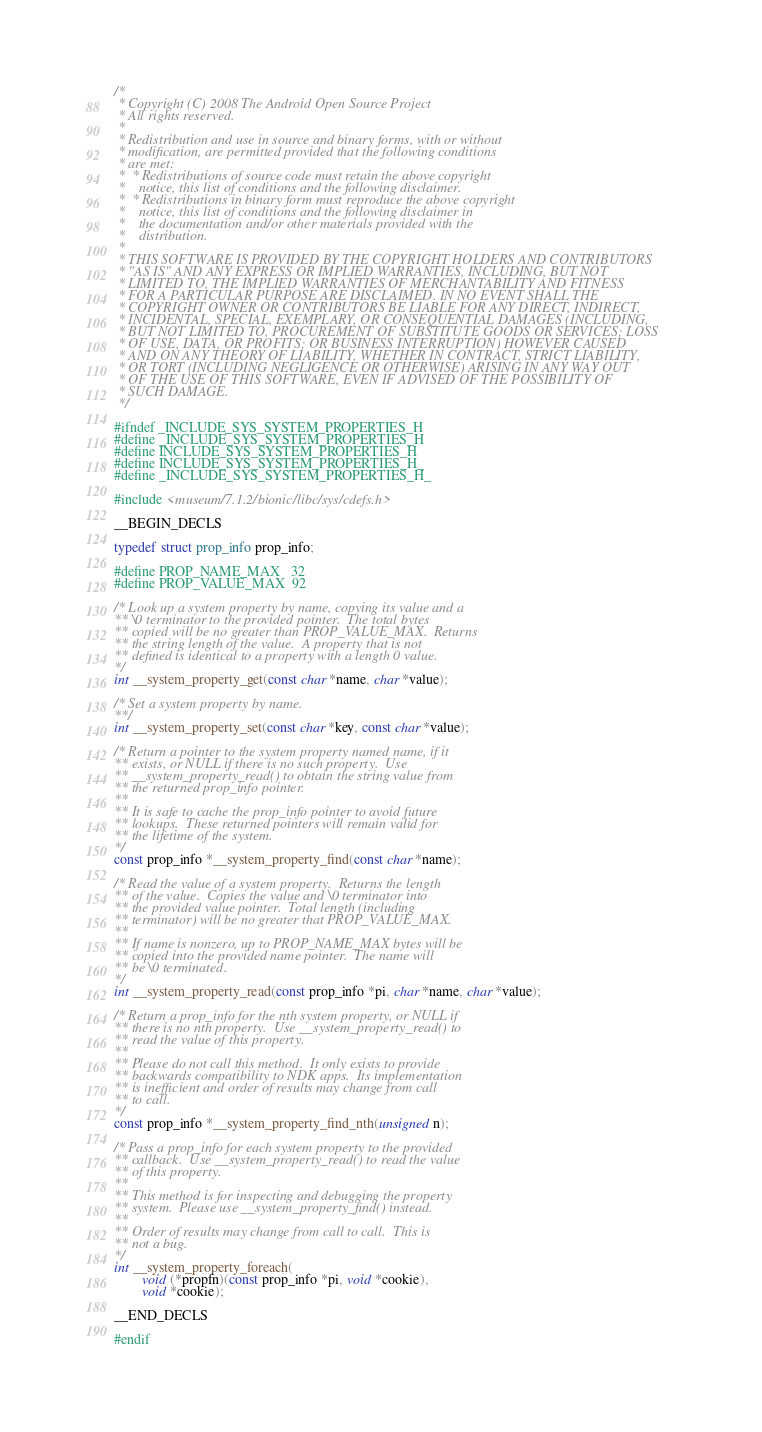Convert code to text. <code><loc_0><loc_0><loc_500><loc_500><_C_>/*
 * Copyright (C) 2008 The Android Open Source Project
 * All rights reserved.
 *
 * Redistribution and use in source and binary forms, with or without
 * modification, are permitted provided that the following conditions
 * are met:
 *  * Redistributions of source code must retain the above copyright
 *    notice, this list of conditions and the following disclaimer.
 *  * Redistributions in binary form must reproduce the above copyright
 *    notice, this list of conditions and the following disclaimer in
 *    the documentation and/or other materials provided with the
 *    distribution.
 *
 * THIS SOFTWARE IS PROVIDED BY THE COPYRIGHT HOLDERS AND CONTRIBUTORS
 * "AS IS" AND ANY EXPRESS OR IMPLIED WARRANTIES, INCLUDING, BUT NOT
 * LIMITED TO, THE IMPLIED WARRANTIES OF MERCHANTABILITY AND FITNESS
 * FOR A PARTICULAR PURPOSE ARE DISCLAIMED. IN NO EVENT SHALL THE
 * COPYRIGHT OWNER OR CONTRIBUTORS BE LIABLE FOR ANY DIRECT, INDIRECT,
 * INCIDENTAL, SPECIAL, EXEMPLARY, OR CONSEQUENTIAL DAMAGES (INCLUDING,
 * BUT NOT LIMITED TO, PROCUREMENT OF SUBSTITUTE GOODS OR SERVICES; LOSS
 * OF USE, DATA, OR PROFITS; OR BUSINESS INTERRUPTION) HOWEVER CAUSED
 * AND ON ANY THEORY OF LIABILITY, WHETHER IN CONTRACT, STRICT LIABILITY,
 * OR TORT (INCLUDING NEGLIGENCE OR OTHERWISE) ARISING IN ANY WAY OUT
 * OF THE USE OF THIS SOFTWARE, EVEN IF ADVISED OF THE POSSIBILITY OF
 * SUCH DAMAGE.
 */

#ifndef _INCLUDE_SYS_SYSTEM_PROPERTIES_H
#define _INCLUDE_SYS_SYSTEM_PROPERTIES_H
#define INCLUDE_SYS_SYSTEM_PROPERTIES_H
#define INCLUDE_SYS_SYSTEM_PROPERTIES_H_
#define _INCLUDE_SYS_SYSTEM_PROPERTIES_H_

#include <museum/7.1.2/bionic/libc/sys/cdefs.h>

__BEGIN_DECLS

typedef struct prop_info prop_info;

#define PROP_NAME_MAX   32
#define PROP_VALUE_MAX  92

/* Look up a system property by name, copying its value and a
** \0 terminator to the provided pointer.  The total bytes
** copied will be no greater than PROP_VALUE_MAX.  Returns
** the string length of the value.  A property that is not
** defined is identical to a property with a length 0 value.
*/
int __system_property_get(const char *name, char *value);

/* Set a system property by name.
**/
int __system_property_set(const char *key, const char *value);

/* Return a pointer to the system property named name, if it
** exists, or NULL if there is no such property.  Use 
** __system_property_read() to obtain the string value from
** the returned prop_info pointer.
**
** It is safe to cache the prop_info pointer to avoid future
** lookups.  These returned pointers will remain valid for
** the lifetime of the system.
*/
const prop_info *__system_property_find(const char *name);

/* Read the value of a system property.  Returns the length
** of the value.  Copies the value and \0 terminator into
** the provided value pointer.  Total length (including
** terminator) will be no greater that PROP_VALUE_MAX.
**
** If name is nonzero, up to PROP_NAME_MAX bytes will be
** copied into the provided name pointer.  The name will
** be \0 terminated.
*/
int __system_property_read(const prop_info *pi, char *name, char *value);

/* Return a prop_info for the nth system property, or NULL if 
** there is no nth property.  Use __system_property_read() to
** read the value of this property.
**
** Please do not call this method.  It only exists to provide
** backwards compatibility to NDK apps.  Its implementation
** is inefficient and order of results may change from call
** to call.
*/ 
const prop_info *__system_property_find_nth(unsigned n);

/* Pass a prop_info for each system property to the provided
** callback.  Use __system_property_read() to read the value
** of this property.
**
** This method is for inspecting and debugging the property
** system.  Please use __system_property_find() instead.
**
** Order of results may change from call to call.  This is
** not a bug.
*/
int __system_property_foreach(
        void (*propfn)(const prop_info *pi, void *cookie),
        void *cookie);

__END_DECLS

#endif
</code> 